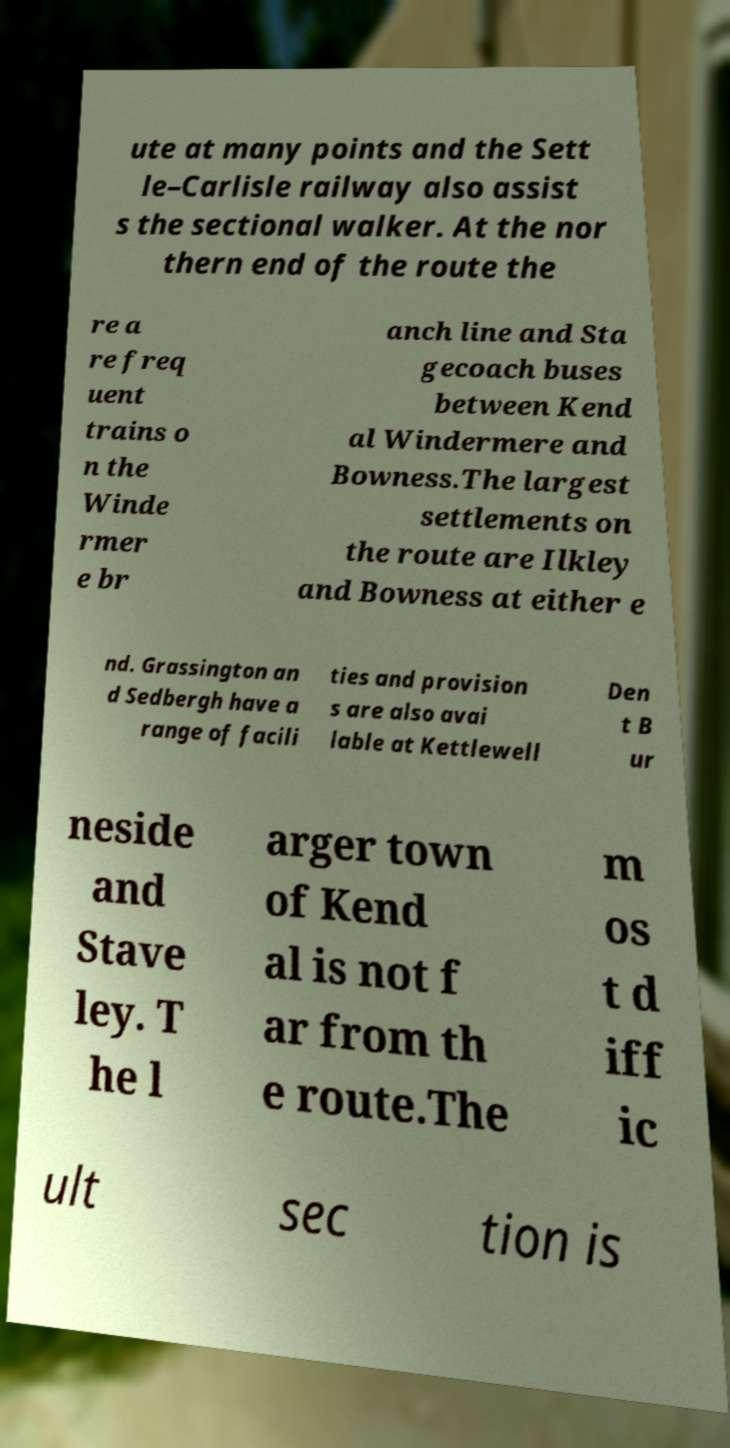Can you accurately transcribe the text from the provided image for me? ute at many points and the Sett le–Carlisle railway also assist s the sectional walker. At the nor thern end of the route the re a re freq uent trains o n the Winde rmer e br anch line and Sta gecoach buses between Kend al Windermere and Bowness.The largest settlements on the route are Ilkley and Bowness at either e nd. Grassington an d Sedbergh have a range of facili ties and provision s are also avai lable at Kettlewell Den t B ur neside and Stave ley. T he l arger town of Kend al is not f ar from th e route.The m os t d iff ic ult sec tion is 